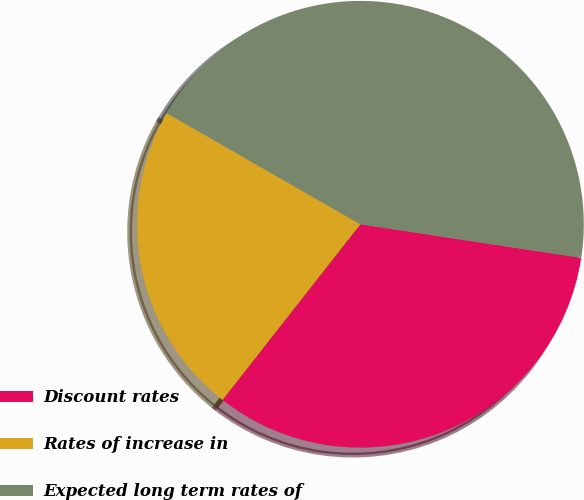Convert chart to OTSL. <chart><loc_0><loc_0><loc_500><loc_500><pie_chart><fcel>Discount rates<fcel>Rates of increase in<fcel>Expected long term rates of<nl><fcel>33.19%<fcel>22.7%<fcel>44.11%<nl></chart> 